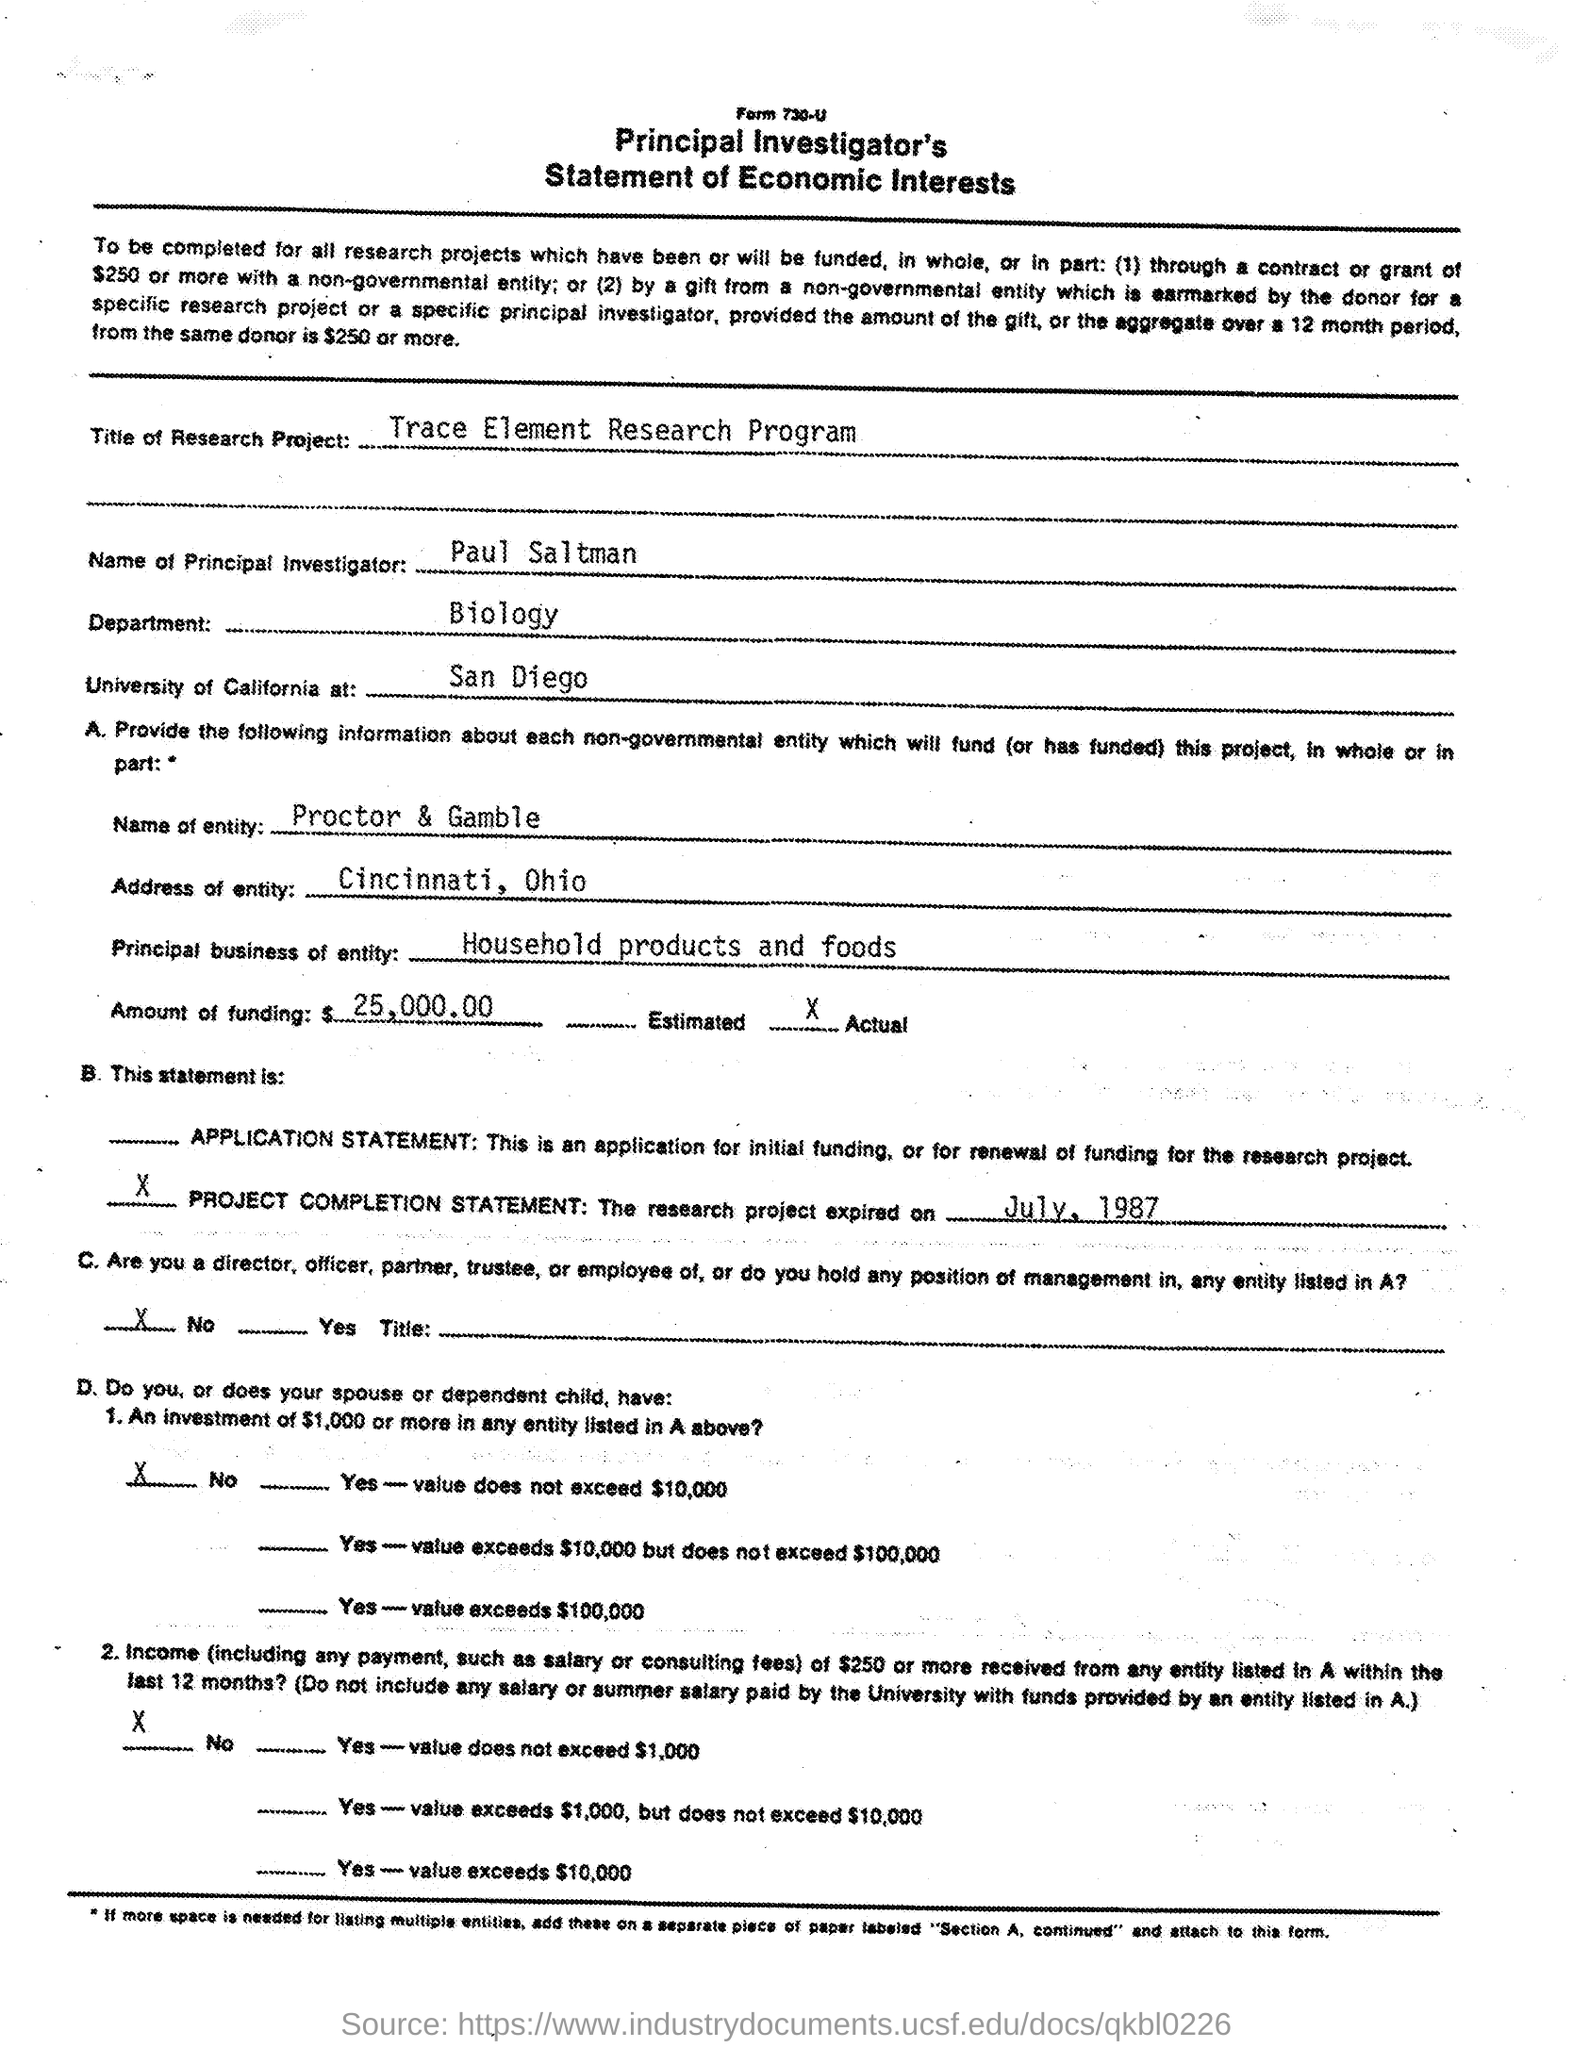What is the title of research project ?
Provide a short and direct response. Trace Element Research program. What is the name of the principal investigator ?
Keep it short and to the point. Paul Saltman. What is the name of department mentioned in the given form ?
Give a very brief answer. Biology. At what place university of california is located ?
Your response must be concise. San Diego. What is the name of entity mentioned in the given form ?
Make the answer very short. Proctor & gamble. What is the address of entity mentioned in the given form ?
Keep it short and to the point. Cincinnati, Ohio. What is the amount of funding mentioned in the given form ?
Give a very brief answer. $ 25,000.00. 